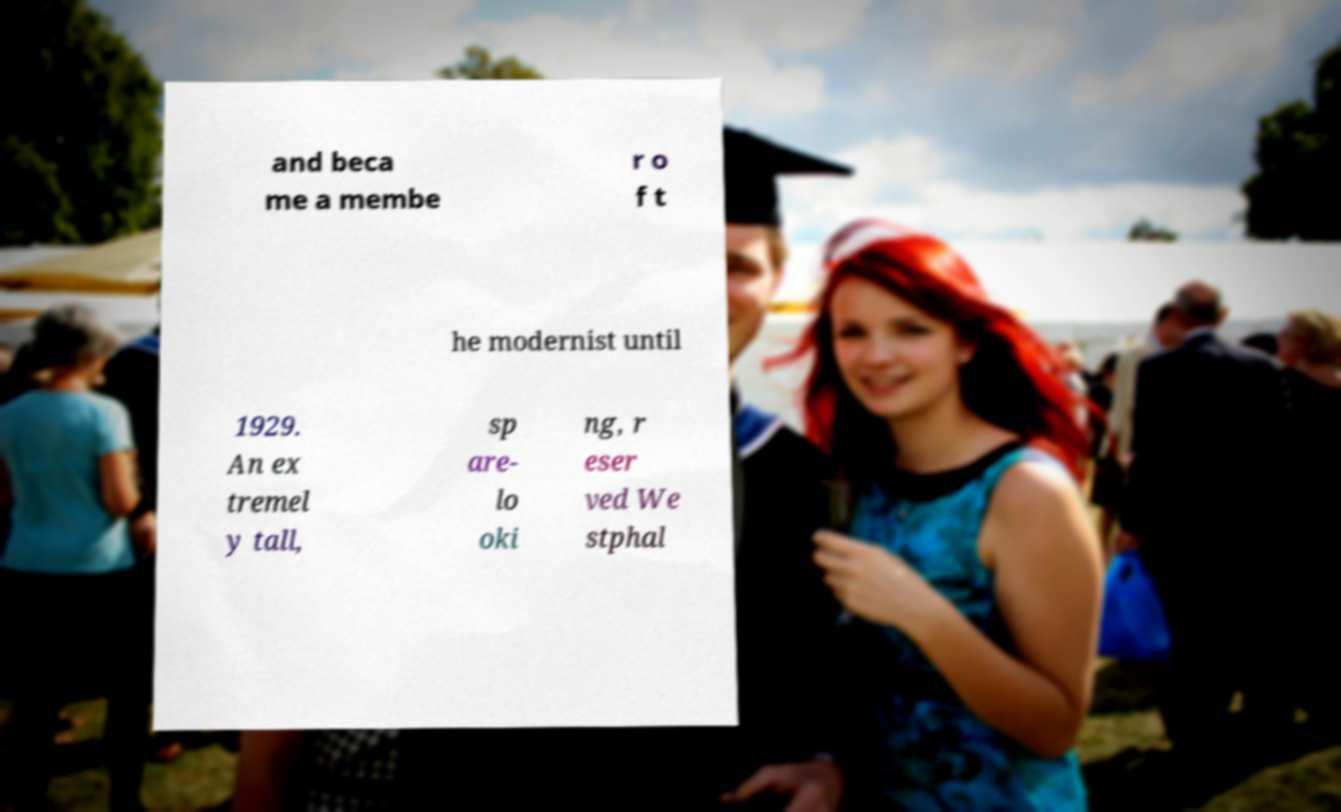Can you read and provide the text displayed in the image?This photo seems to have some interesting text. Can you extract and type it out for me? and beca me a membe r o f t he modernist until 1929. An ex tremel y tall, sp are- lo oki ng, r eser ved We stphal 